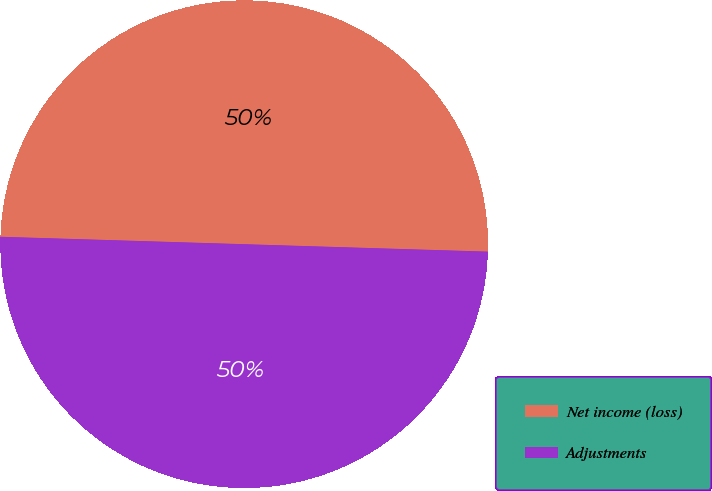Convert chart. <chart><loc_0><loc_0><loc_500><loc_500><pie_chart><fcel>Net income (loss)<fcel>Adjustments<nl><fcel>50.0%<fcel>50.0%<nl></chart> 